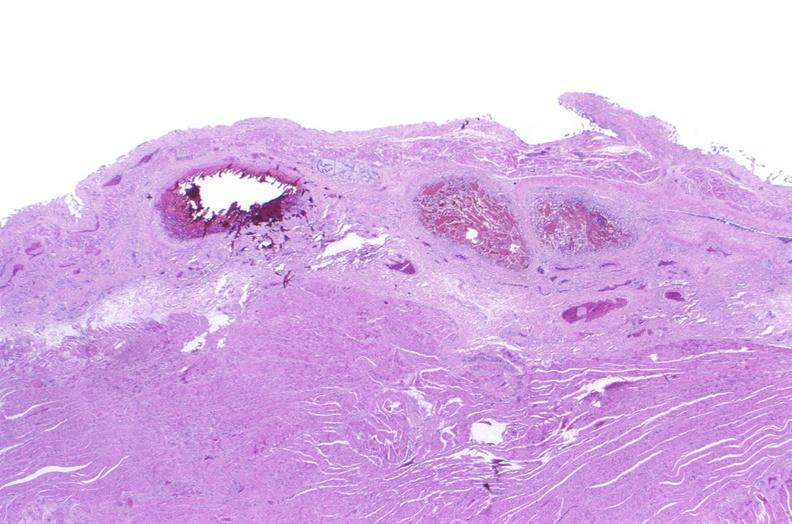what is present?
Answer the question using a single word or phrase. Gastrointestinal 